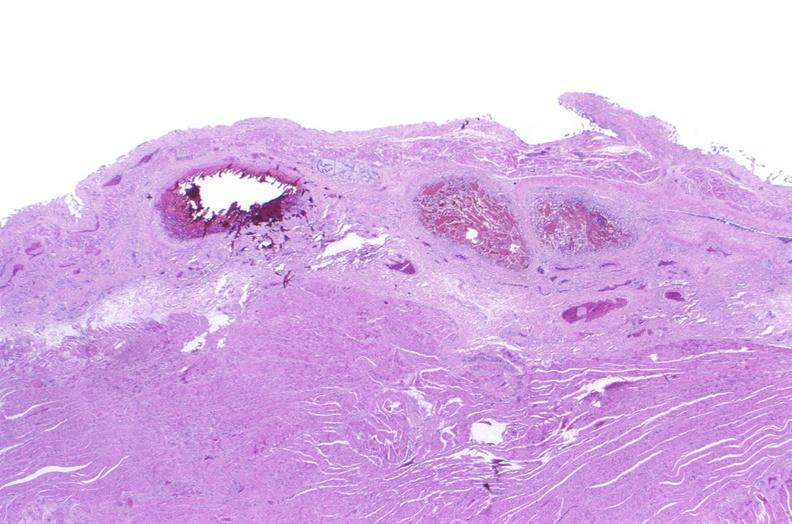what is present?
Answer the question using a single word or phrase. Gastrointestinal 